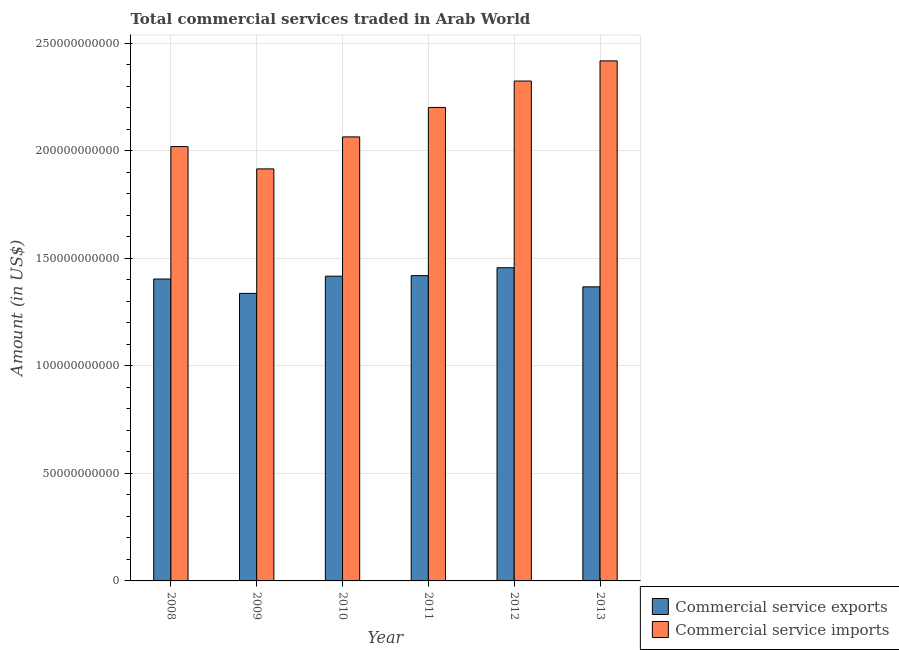How many different coloured bars are there?
Keep it short and to the point. 2. How many groups of bars are there?
Give a very brief answer. 6. Are the number of bars per tick equal to the number of legend labels?
Make the answer very short. Yes. What is the label of the 2nd group of bars from the left?
Keep it short and to the point. 2009. In how many cases, is the number of bars for a given year not equal to the number of legend labels?
Give a very brief answer. 0. What is the amount of commercial service exports in 2008?
Provide a succinct answer. 1.40e+11. Across all years, what is the maximum amount of commercial service imports?
Offer a terse response. 2.42e+11. Across all years, what is the minimum amount of commercial service exports?
Give a very brief answer. 1.34e+11. What is the total amount of commercial service imports in the graph?
Keep it short and to the point. 1.29e+12. What is the difference between the amount of commercial service exports in 2009 and that in 2013?
Your answer should be very brief. -3.04e+09. What is the difference between the amount of commercial service imports in 2010 and the amount of commercial service exports in 2009?
Provide a succinct answer. 1.49e+1. What is the average amount of commercial service imports per year?
Make the answer very short. 2.16e+11. In how many years, is the amount of commercial service exports greater than 130000000000 US$?
Keep it short and to the point. 6. What is the ratio of the amount of commercial service exports in 2011 to that in 2012?
Your answer should be compact. 0.97. Is the amount of commercial service imports in 2012 less than that in 2013?
Provide a succinct answer. Yes. Is the difference between the amount of commercial service exports in 2008 and 2009 greater than the difference between the amount of commercial service imports in 2008 and 2009?
Keep it short and to the point. No. What is the difference between the highest and the second highest amount of commercial service exports?
Provide a short and direct response. 3.68e+09. What is the difference between the highest and the lowest amount of commercial service exports?
Give a very brief answer. 1.19e+1. In how many years, is the amount of commercial service imports greater than the average amount of commercial service imports taken over all years?
Your answer should be very brief. 3. What does the 1st bar from the left in 2008 represents?
Provide a succinct answer. Commercial service exports. What does the 2nd bar from the right in 2012 represents?
Give a very brief answer. Commercial service exports. How many bars are there?
Make the answer very short. 12. Are all the bars in the graph horizontal?
Your answer should be compact. No. How many years are there in the graph?
Your answer should be very brief. 6. What is the difference between two consecutive major ticks on the Y-axis?
Offer a terse response. 5.00e+1. Does the graph contain any zero values?
Give a very brief answer. No. Does the graph contain grids?
Offer a very short reply. Yes. How are the legend labels stacked?
Your answer should be compact. Vertical. What is the title of the graph?
Provide a succinct answer. Total commercial services traded in Arab World. Does "RDB nonconcessional" appear as one of the legend labels in the graph?
Give a very brief answer. No. What is the label or title of the Y-axis?
Offer a very short reply. Amount (in US$). What is the Amount (in US$) in Commercial service exports in 2008?
Offer a terse response. 1.40e+11. What is the Amount (in US$) of Commercial service imports in 2008?
Provide a short and direct response. 2.02e+11. What is the Amount (in US$) in Commercial service exports in 2009?
Your answer should be compact. 1.34e+11. What is the Amount (in US$) of Commercial service imports in 2009?
Your answer should be compact. 1.92e+11. What is the Amount (in US$) in Commercial service exports in 2010?
Provide a succinct answer. 1.42e+11. What is the Amount (in US$) in Commercial service imports in 2010?
Your response must be concise. 2.06e+11. What is the Amount (in US$) in Commercial service exports in 2011?
Provide a succinct answer. 1.42e+11. What is the Amount (in US$) in Commercial service imports in 2011?
Keep it short and to the point. 2.20e+11. What is the Amount (in US$) of Commercial service exports in 2012?
Give a very brief answer. 1.46e+11. What is the Amount (in US$) of Commercial service imports in 2012?
Your response must be concise. 2.32e+11. What is the Amount (in US$) of Commercial service exports in 2013?
Your answer should be very brief. 1.37e+11. What is the Amount (in US$) in Commercial service imports in 2013?
Provide a succinct answer. 2.42e+11. Across all years, what is the maximum Amount (in US$) in Commercial service exports?
Ensure brevity in your answer.  1.46e+11. Across all years, what is the maximum Amount (in US$) in Commercial service imports?
Offer a terse response. 2.42e+11. Across all years, what is the minimum Amount (in US$) of Commercial service exports?
Make the answer very short. 1.34e+11. Across all years, what is the minimum Amount (in US$) in Commercial service imports?
Your answer should be very brief. 1.92e+11. What is the total Amount (in US$) of Commercial service exports in the graph?
Provide a succinct answer. 8.40e+11. What is the total Amount (in US$) of Commercial service imports in the graph?
Your answer should be very brief. 1.29e+12. What is the difference between the Amount (in US$) of Commercial service exports in 2008 and that in 2009?
Ensure brevity in your answer.  6.68e+09. What is the difference between the Amount (in US$) in Commercial service imports in 2008 and that in 2009?
Your response must be concise. 1.04e+1. What is the difference between the Amount (in US$) in Commercial service exports in 2008 and that in 2010?
Your answer should be very brief. -1.31e+09. What is the difference between the Amount (in US$) of Commercial service imports in 2008 and that in 2010?
Give a very brief answer. -4.51e+09. What is the difference between the Amount (in US$) of Commercial service exports in 2008 and that in 2011?
Keep it short and to the point. -1.56e+09. What is the difference between the Amount (in US$) in Commercial service imports in 2008 and that in 2011?
Your answer should be compact. -1.82e+1. What is the difference between the Amount (in US$) of Commercial service exports in 2008 and that in 2012?
Give a very brief answer. -5.24e+09. What is the difference between the Amount (in US$) of Commercial service imports in 2008 and that in 2012?
Make the answer very short. -3.05e+1. What is the difference between the Amount (in US$) of Commercial service exports in 2008 and that in 2013?
Your answer should be compact. 3.64e+09. What is the difference between the Amount (in US$) in Commercial service imports in 2008 and that in 2013?
Keep it short and to the point. -3.98e+1. What is the difference between the Amount (in US$) in Commercial service exports in 2009 and that in 2010?
Provide a short and direct response. -7.99e+09. What is the difference between the Amount (in US$) in Commercial service imports in 2009 and that in 2010?
Your response must be concise. -1.49e+1. What is the difference between the Amount (in US$) in Commercial service exports in 2009 and that in 2011?
Your answer should be very brief. -8.24e+09. What is the difference between the Amount (in US$) in Commercial service imports in 2009 and that in 2011?
Your answer should be compact. -2.85e+1. What is the difference between the Amount (in US$) in Commercial service exports in 2009 and that in 2012?
Give a very brief answer. -1.19e+1. What is the difference between the Amount (in US$) in Commercial service imports in 2009 and that in 2012?
Offer a terse response. -4.08e+1. What is the difference between the Amount (in US$) of Commercial service exports in 2009 and that in 2013?
Your answer should be compact. -3.04e+09. What is the difference between the Amount (in US$) of Commercial service imports in 2009 and that in 2013?
Provide a succinct answer. -5.02e+1. What is the difference between the Amount (in US$) of Commercial service exports in 2010 and that in 2011?
Provide a succinct answer. -2.50e+08. What is the difference between the Amount (in US$) in Commercial service imports in 2010 and that in 2011?
Offer a terse response. -1.37e+1. What is the difference between the Amount (in US$) of Commercial service exports in 2010 and that in 2012?
Your answer should be compact. -3.93e+09. What is the difference between the Amount (in US$) in Commercial service imports in 2010 and that in 2012?
Ensure brevity in your answer.  -2.60e+1. What is the difference between the Amount (in US$) in Commercial service exports in 2010 and that in 2013?
Make the answer very short. 4.95e+09. What is the difference between the Amount (in US$) in Commercial service imports in 2010 and that in 2013?
Offer a very short reply. -3.53e+1. What is the difference between the Amount (in US$) in Commercial service exports in 2011 and that in 2012?
Offer a very short reply. -3.68e+09. What is the difference between the Amount (in US$) in Commercial service imports in 2011 and that in 2012?
Offer a terse response. -1.23e+1. What is the difference between the Amount (in US$) in Commercial service exports in 2011 and that in 2013?
Ensure brevity in your answer.  5.20e+09. What is the difference between the Amount (in US$) in Commercial service imports in 2011 and that in 2013?
Ensure brevity in your answer.  -2.17e+1. What is the difference between the Amount (in US$) of Commercial service exports in 2012 and that in 2013?
Your response must be concise. 8.88e+09. What is the difference between the Amount (in US$) of Commercial service imports in 2012 and that in 2013?
Your response must be concise. -9.37e+09. What is the difference between the Amount (in US$) in Commercial service exports in 2008 and the Amount (in US$) in Commercial service imports in 2009?
Give a very brief answer. -5.12e+1. What is the difference between the Amount (in US$) of Commercial service exports in 2008 and the Amount (in US$) of Commercial service imports in 2010?
Your response must be concise. -6.61e+1. What is the difference between the Amount (in US$) of Commercial service exports in 2008 and the Amount (in US$) of Commercial service imports in 2011?
Offer a terse response. -7.97e+1. What is the difference between the Amount (in US$) of Commercial service exports in 2008 and the Amount (in US$) of Commercial service imports in 2012?
Offer a very short reply. -9.20e+1. What is the difference between the Amount (in US$) in Commercial service exports in 2008 and the Amount (in US$) in Commercial service imports in 2013?
Give a very brief answer. -1.01e+11. What is the difference between the Amount (in US$) of Commercial service exports in 2009 and the Amount (in US$) of Commercial service imports in 2010?
Your response must be concise. -7.27e+1. What is the difference between the Amount (in US$) of Commercial service exports in 2009 and the Amount (in US$) of Commercial service imports in 2011?
Provide a succinct answer. -8.64e+1. What is the difference between the Amount (in US$) in Commercial service exports in 2009 and the Amount (in US$) in Commercial service imports in 2012?
Offer a terse response. -9.87e+1. What is the difference between the Amount (in US$) of Commercial service exports in 2009 and the Amount (in US$) of Commercial service imports in 2013?
Provide a short and direct response. -1.08e+11. What is the difference between the Amount (in US$) of Commercial service exports in 2010 and the Amount (in US$) of Commercial service imports in 2011?
Your answer should be compact. -7.84e+1. What is the difference between the Amount (in US$) in Commercial service exports in 2010 and the Amount (in US$) in Commercial service imports in 2012?
Provide a short and direct response. -9.07e+1. What is the difference between the Amount (in US$) in Commercial service exports in 2010 and the Amount (in US$) in Commercial service imports in 2013?
Your response must be concise. -1.00e+11. What is the difference between the Amount (in US$) of Commercial service exports in 2011 and the Amount (in US$) of Commercial service imports in 2012?
Provide a short and direct response. -9.05e+1. What is the difference between the Amount (in US$) in Commercial service exports in 2011 and the Amount (in US$) in Commercial service imports in 2013?
Your response must be concise. -9.98e+1. What is the difference between the Amount (in US$) of Commercial service exports in 2012 and the Amount (in US$) of Commercial service imports in 2013?
Make the answer very short. -9.62e+1. What is the average Amount (in US$) of Commercial service exports per year?
Offer a very short reply. 1.40e+11. What is the average Amount (in US$) of Commercial service imports per year?
Your response must be concise. 2.16e+11. In the year 2008, what is the difference between the Amount (in US$) of Commercial service exports and Amount (in US$) of Commercial service imports?
Keep it short and to the point. -6.15e+1. In the year 2009, what is the difference between the Amount (in US$) of Commercial service exports and Amount (in US$) of Commercial service imports?
Offer a very short reply. -5.79e+1. In the year 2010, what is the difference between the Amount (in US$) of Commercial service exports and Amount (in US$) of Commercial service imports?
Offer a very short reply. -6.47e+1. In the year 2011, what is the difference between the Amount (in US$) in Commercial service exports and Amount (in US$) in Commercial service imports?
Provide a succinct answer. -7.82e+1. In the year 2012, what is the difference between the Amount (in US$) in Commercial service exports and Amount (in US$) in Commercial service imports?
Give a very brief answer. -8.68e+1. In the year 2013, what is the difference between the Amount (in US$) in Commercial service exports and Amount (in US$) in Commercial service imports?
Your answer should be compact. -1.05e+11. What is the ratio of the Amount (in US$) in Commercial service exports in 2008 to that in 2009?
Make the answer very short. 1.05. What is the ratio of the Amount (in US$) in Commercial service imports in 2008 to that in 2009?
Provide a succinct answer. 1.05. What is the ratio of the Amount (in US$) in Commercial service imports in 2008 to that in 2010?
Your response must be concise. 0.98. What is the ratio of the Amount (in US$) of Commercial service imports in 2008 to that in 2011?
Provide a succinct answer. 0.92. What is the ratio of the Amount (in US$) of Commercial service exports in 2008 to that in 2012?
Offer a terse response. 0.96. What is the ratio of the Amount (in US$) in Commercial service imports in 2008 to that in 2012?
Provide a succinct answer. 0.87. What is the ratio of the Amount (in US$) of Commercial service exports in 2008 to that in 2013?
Keep it short and to the point. 1.03. What is the ratio of the Amount (in US$) in Commercial service imports in 2008 to that in 2013?
Ensure brevity in your answer.  0.84. What is the ratio of the Amount (in US$) of Commercial service exports in 2009 to that in 2010?
Give a very brief answer. 0.94. What is the ratio of the Amount (in US$) of Commercial service imports in 2009 to that in 2010?
Keep it short and to the point. 0.93. What is the ratio of the Amount (in US$) of Commercial service exports in 2009 to that in 2011?
Ensure brevity in your answer.  0.94. What is the ratio of the Amount (in US$) of Commercial service imports in 2009 to that in 2011?
Offer a terse response. 0.87. What is the ratio of the Amount (in US$) in Commercial service exports in 2009 to that in 2012?
Your answer should be very brief. 0.92. What is the ratio of the Amount (in US$) of Commercial service imports in 2009 to that in 2012?
Your response must be concise. 0.82. What is the ratio of the Amount (in US$) in Commercial service exports in 2009 to that in 2013?
Give a very brief answer. 0.98. What is the ratio of the Amount (in US$) of Commercial service imports in 2009 to that in 2013?
Ensure brevity in your answer.  0.79. What is the ratio of the Amount (in US$) of Commercial service imports in 2010 to that in 2011?
Your answer should be very brief. 0.94. What is the ratio of the Amount (in US$) in Commercial service exports in 2010 to that in 2012?
Offer a very short reply. 0.97. What is the ratio of the Amount (in US$) of Commercial service imports in 2010 to that in 2012?
Give a very brief answer. 0.89. What is the ratio of the Amount (in US$) of Commercial service exports in 2010 to that in 2013?
Make the answer very short. 1.04. What is the ratio of the Amount (in US$) in Commercial service imports in 2010 to that in 2013?
Offer a very short reply. 0.85. What is the ratio of the Amount (in US$) in Commercial service exports in 2011 to that in 2012?
Give a very brief answer. 0.97. What is the ratio of the Amount (in US$) of Commercial service imports in 2011 to that in 2012?
Your answer should be very brief. 0.95. What is the ratio of the Amount (in US$) in Commercial service exports in 2011 to that in 2013?
Provide a short and direct response. 1.04. What is the ratio of the Amount (in US$) of Commercial service imports in 2011 to that in 2013?
Give a very brief answer. 0.91. What is the ratio of the Amount (in US$) in Commercial service exports in 2012 to that in 2013?
Offer a terse response. 1.06. What is the ratio of the Amount (in US$) of Commercial service imports in 2012 to that in 2013?
Give a very brief answer. 0.96. What is the difference between the highest and the second highest Amount (in US$) of Commercial service exports?
Your answer should be compact. 3.68e+09. What is the difference between the highest and the second highest Amount (in US$) of Commercial service imports?
Offer a very short reply. 9.37e+09. What is the difference between the highest and the lowest Amount (in US$) in Commercial service exports?
Keep it short and to the point. 1.19e+1. What is the difference between the highest and the lowest Amount (in US$) of Commercial service imports?
Offer a very short reply. 5.02e+1. 